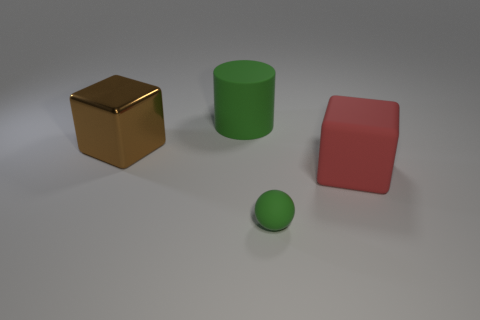Is there any other thing that is the same size as the green matte sphere?
Your answer should be very brief. No. Is there anything else that is the same shape as the small green matte object?
Your response must be concise. No. Are there fewer big green cylinders that are in front of the red block than things that are left of the green matte sphere?
Make the answer very short. Yes. What number of other objects have the same material as the small green thing?
Give a very brief answer. 2. There is a brown object; is its size the same as the green rubber sphere in front of the big brown thing?
Offer a very short reply. No. There is another object that is the same color as the tiny matte thing; what is its material?
Ensure brevity in your answer.  Rubber. There is a green object on the left side of the green object that is in front of the block on the right side of the large green object; what is its size?
Keep it short and to the point. Large. Are there more big matte things that are in front of the green cylinder than small green spheres that are on the left side of the metal object?
Offer a very short reply. Yes. There is a green thing that is in front of the large red rubber cube; how many green things are in front of it?
Provide a succinct answer. 0. Is there a small thing that has the same color as the big cylinder?
Provide a short and direct response. Yes. 